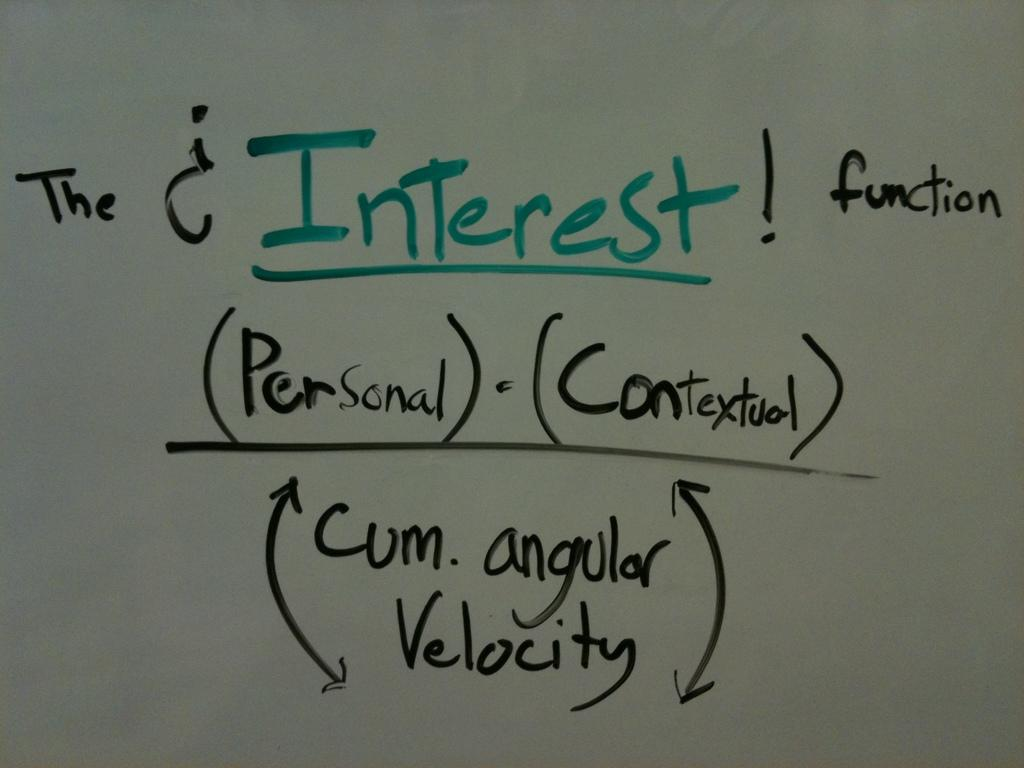<image>
Provide a brief description of the given image. A white board has Interest written on it in green 